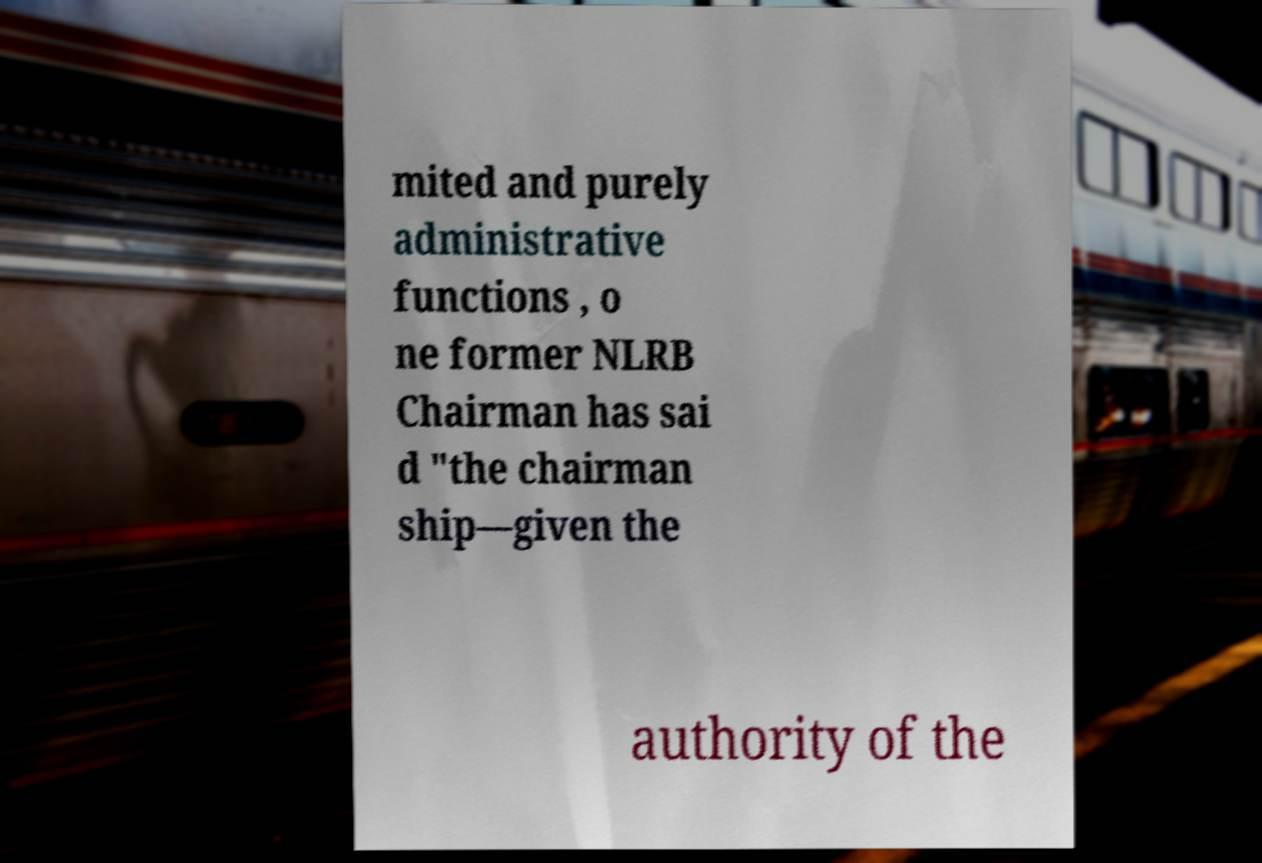For documentation purposes, I need the text within this image transcribed. Could you provide that? mited and purely administrative functions , o ne former NLRB Chairman has sai d "the chairman ship—given the authority of the 